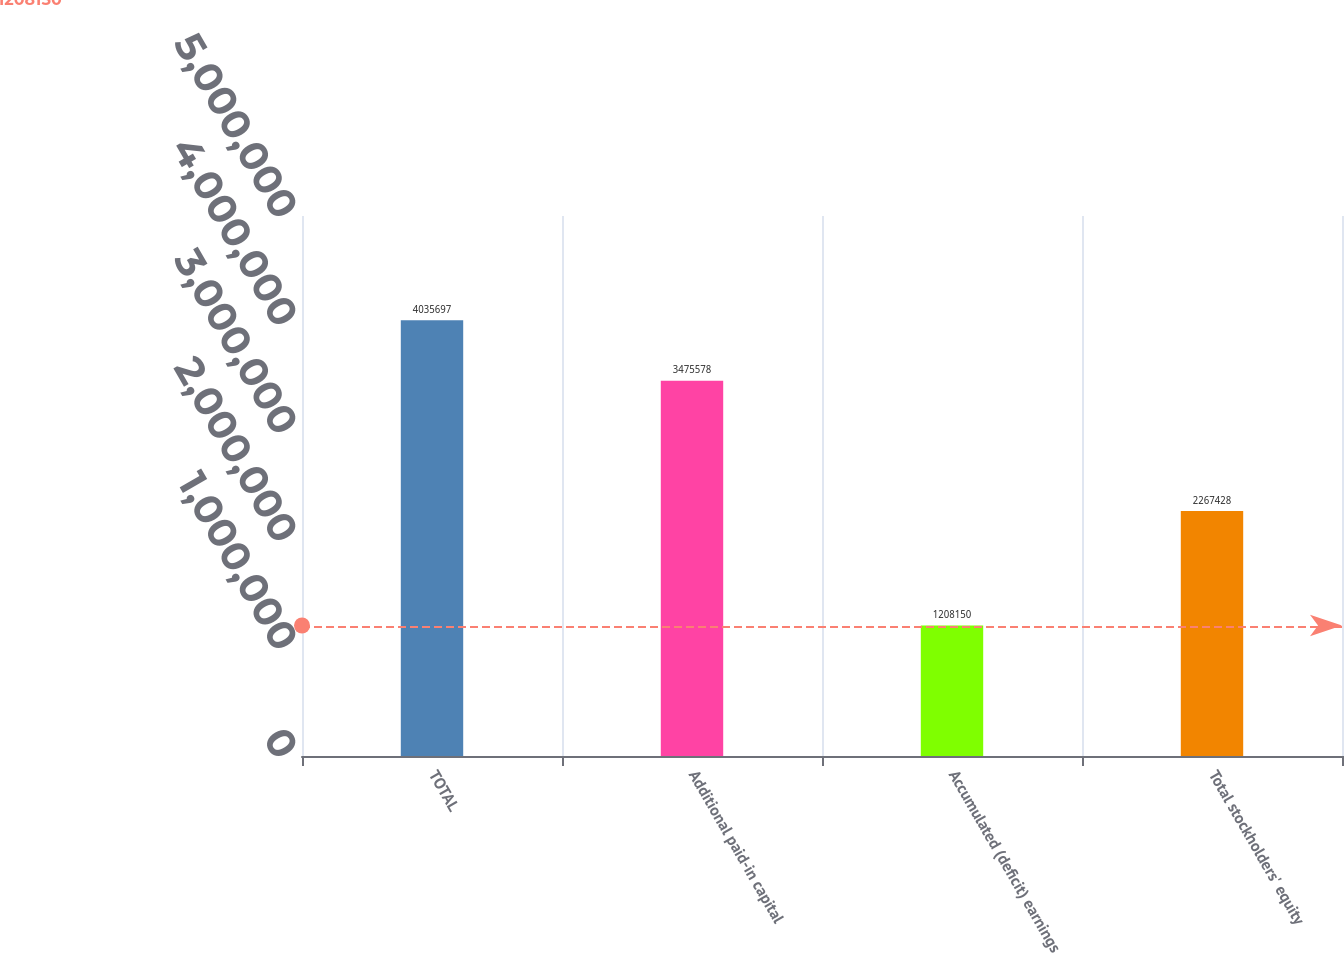<chart> <loc_0><loc_0><loc_500><loc_500><bar_chart><fcel>TOTAL<fcel>Additional paid-in capital<fcel>Accumulated (deficit) earnings<fcel>Total stockholders' equity<nl><fcel>4.0357e+06<fcel>3.47558e+06<fcel>1.20815e+06<fcel>2.26743e+06<nl></chart> 